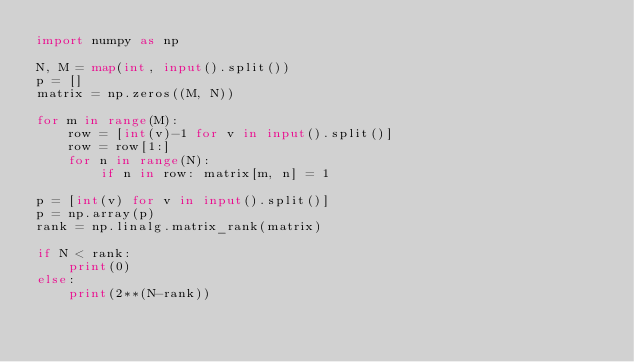Convert code to text. <code><loc_0><loc_0><loc_500><loc_500><_Python_>import numpy as np

N, M = map(int, input().split())
p = []
matrix = np.zeros((M, N))

for m in range(M):
    row = [int(v)-1 for v in input().split()]
    row = row[1:]
    for n in range(N):
        if n in row: matrix[m, n] = 1

p = [int(v) for v in input().split()]
p = np.array(p)
rank = np.linalg.matrix_rank(matrix)

if N < rank:
    print(0)
else:
    print(2**(N-rank))

</code> 